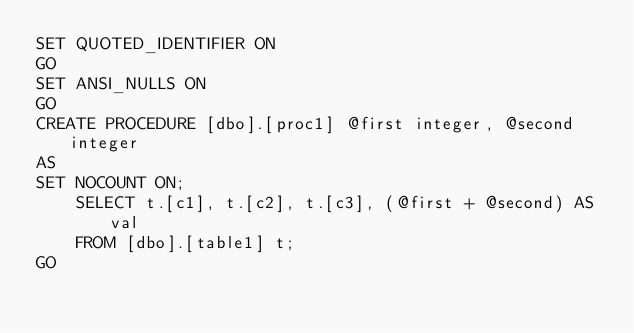Convert code to text. <code><loc_0><loc_0><loc_500><loc_500><_SQL_>SET QUOTED_IDENTIFIER ON
GO
SET ANSI_NULLS ON
GO
CREATE PROCEDURE [dbo].[proc1] @first integer, @second integer
AS
SET NOCOUNT ON;  
    SELECT t.[c1], t.[c2], t.[c3], (@first + @second) AS val  
    FROM [dbo].[table1] t;
GO</code> 